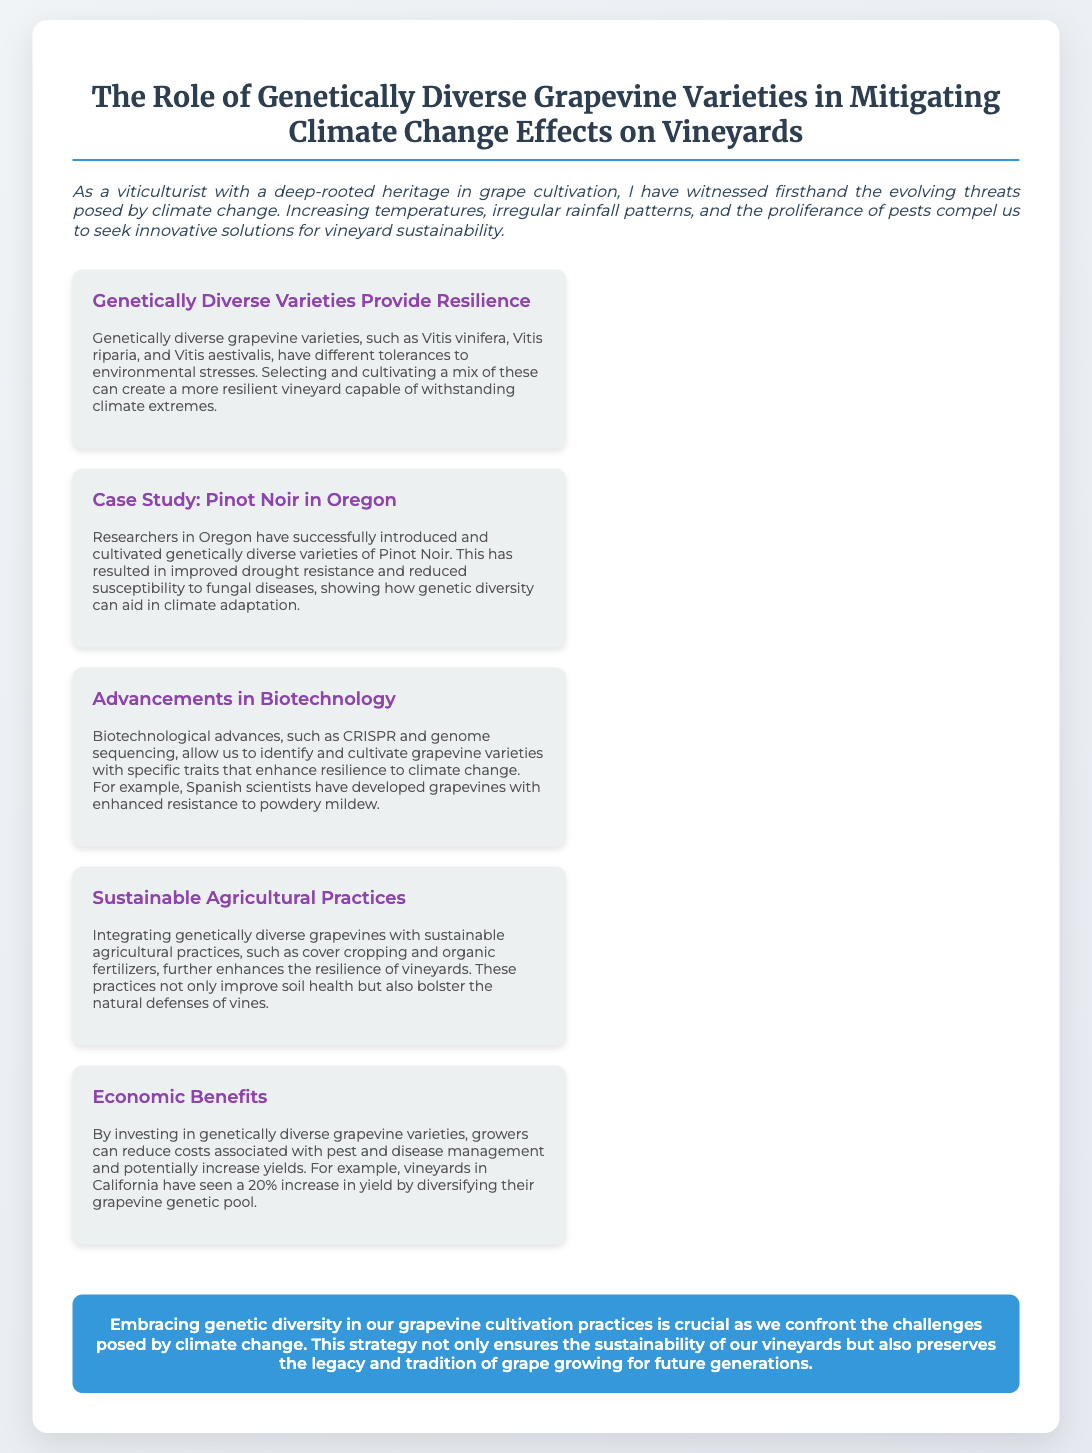What is the title of the presentation? The title of the presentation is explicitly mentioned at the top of the document.
Answer: The Role of Genetically Diverse Grapevine Varieties in Mitigating Climate Change Effects on Vineyards Which grapevine variety is highlighted in the Oregon case study? The case study specifically mentions a variety cultivated in Oregon as an example of genetic diversity in grapevines.
Answer: Pinot Noir What biotechnological advances are mentioned in the document? The document references specific biotechnological advancements that aid in grapevine cultivation.
Answer: CRISPR and genome sequencing What percentage increase in yield did vineyards in California see? The document provides a specific statistic regarding the yield increase due to genetic diversity.
Answer: 20% What sustainable practice is mentioned alongside genetically diverse grapevines? A practice that enhances vineyard resilience is discussed in conjunction with grapevine diversity.
Answer: Cover cropping 